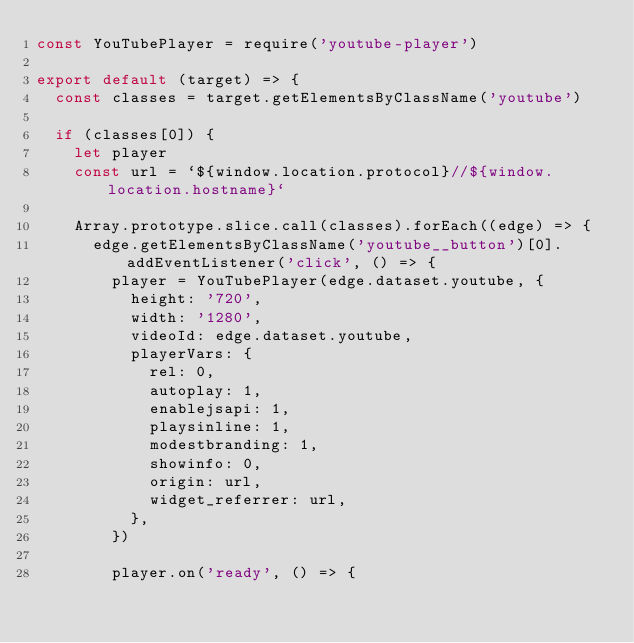<code> <loc_0><loc_0><loc_500><loc_500><_JavaScript_>const YouTubePlayer = require('youtube-player')

export default (target) => {
  const classes = target.getElementsByClassName('youtube')

  if (classes[0]) {
    let player
    const url = `${window.location.protocol}//${window.location.hostname}`

    Array.prototype.slice.call(classes).forEach((edge) => {
      edge.getElementsByClassName('youtube__button')[0].addEventListener('click', () => {
        player = YouTubePlayer(edge.dataset.youtube, {
          height: '720',
          width: '1280',
          videoId: edge.dataset.youtube,
          playerVars: {
            rel: 0,
            autoplay: 1,
            enablejsapi: 1,
            playsinline: 1,
            modestbranding: 1,
            showinfo: 0,
            origin: url,
            widget_referrer: url,
          },
        })

        player.on('ready', () => {</code> 